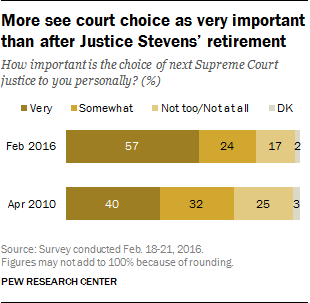Indicate a few pertinent items in this graphic. In 2016, people were more likely to choose very important when given the options of "not important at all," "important," and "very important." However, in 20210, people were less likely to choose "very important" as their top option. A large percentage of individuals chose the "don't know" option in February 2016. 